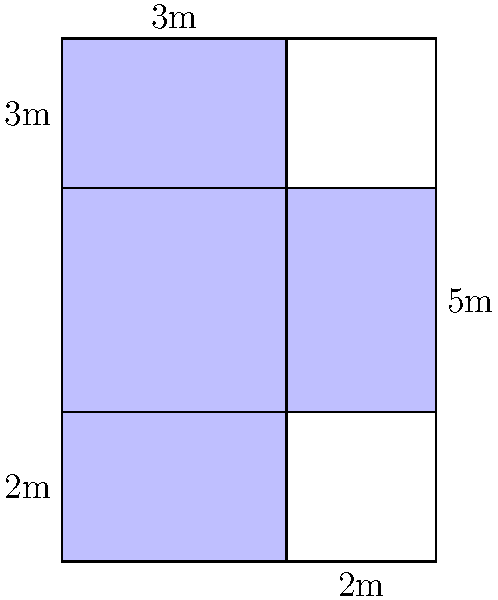In our parish, we are planning to renovate the floor of our cross-shaped church. The floor plan is shown above, with dimensions given in meters. As a devoted member of the congregation, you've been asked to calculate the total area of the church floor to determine the amount of material needed. What is the total area of the church floor in square meters? Let us approach this step-by-step, guided by our faith and reason:

1) The church floor can be divided into two rectangles: the main body and the transept.

2) For the main body (vertical part):
   Length = 7m
   Width = 3m
   Area of main body = $7 \times 3 = 21$ sq m

3) For the transept (horizontal part):
   Length = 5m
   Width = 2m
   Area of transept = $5 \times 2 = 10$ sq m

4) However, we've counted the intersection twice. We need to subtract this:
   Intersection area = $3 \times 2 = 6$ sq m

5) Therefore, the total area is:
   Total Area = Area of main body + Area of transept - Area of intersection
               = $21 + 10 - 6 = 25$ sq m

Thus, with God's guidance, we've calculated that the total area of our church floor is 25 square meters.
Answer: 25 sq m 